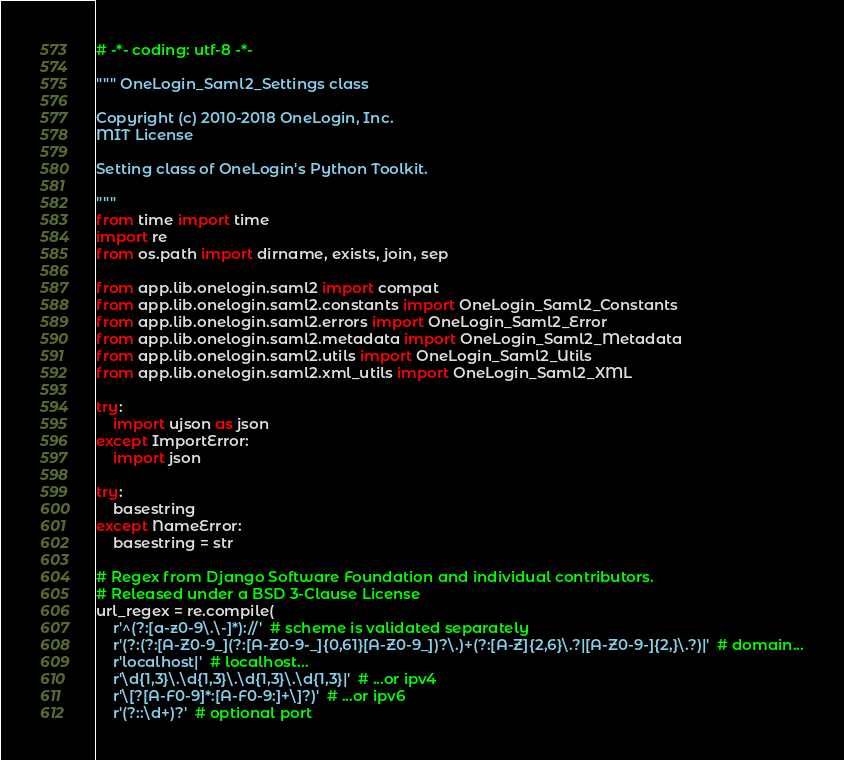<code> <loc_0><loc_0><loc_500><loc_500><_Python_># -*- coding: utf-8 -*-

""" OneLogin_Saml2_Settings class

Copyright (c) 2010-2018 OneLogin, Inc.
MIT License

Setting class of OneLogin's Python Toolkit.

"""
from time import time
import re
from os.path import dirname, exists, join, sep

from app.lib.onelogin.saml2 import compat
from app.lib.onelogin.saml2.constants import OneLogin_Saml2_Constants
from app.lib.onelogin.saml2.errors import OneLogin_Saml2_Error
from app.lib.onelogin.saml2.metadata import OneLogin_Saml2_Metadata
from app.lib.onelogin.saml2.utils import OneLogin_Saml2_Utils
from app.lib.onelogin.saml2.xml_utils import OneLogin_Saml2_XML

try:
    import ujson as json
except ImportError:
    import json

try:
    basestring
except NameError:
    basestring = str

# Regex from Django Software Foundation and individual contributors.
# Released under a BSD 3-Clause License
url_regex = re.compile(
    r'^(?:[a-z0-9\.\-]*)://'  # scheme is validated separately
    r'(?:(?:[A-Z0-9_](?:[A-Z0-9-_]{0,61}[A-Z0-9_])?\.)+(?:[A-Z]{2,6}\.?|[A-Z0-9-]{2,}\.?)|'  # domain...
    r'localhost|'  # localhost...
    r'\d{1,3}\.\d{1,3}\.\d{1,3}\.\d{1,3}|'  # ...or ipv4
    r'\[?[A-F0-9]*:[A-F0-9:]+\]?)'  # ...or ipv6
    r'(?::\d+)?'  # optional port</code> 